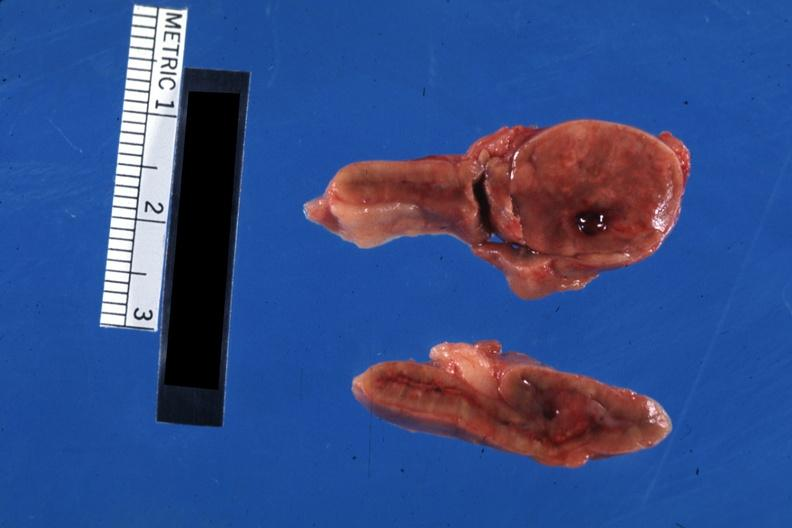s cortical nodule present?
Answer the question using a single word or phrase. Yes 